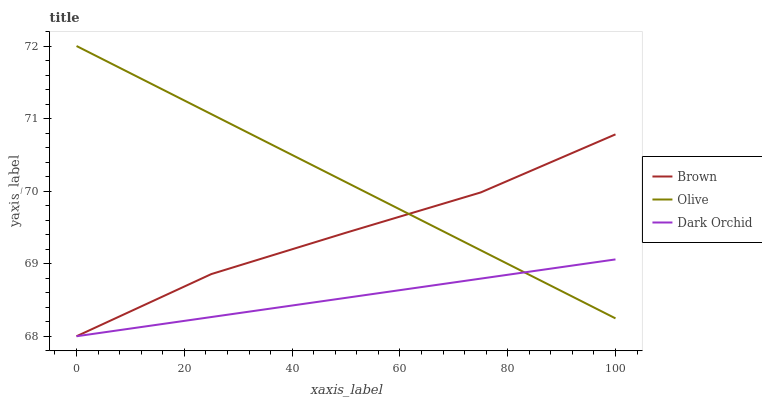Does Dark Orchid have the minimum area under the curve?
Answer yes or no. Yes. Does Olive have the maximum area under the curve?
Answer yes or no. Yes. Does Brown have the minimum area under the curve?
Answer yes or no. No. Does Brown have the maximum area under the curve?
Answer yes or no. No. Is Dark Orchid the smoothest?
Answer yes or no. Yes. Is Brown the roughest?
Answer yes or no. Yes. Is Brown the smoothest?
Answer yes or no. No. Is Dark Orchid the roughest?
Answer yes or no. No. Does Olive have the highest value?
Answer yes or no. Yes. Does Brown have the highest value?
Answer yes or no. No. Does Brown intersect Olive?
Answer yes or no. Yes. Is Brown less than Olive?
Answer yes or no. No. Is Brown greater than Olive?
Answer yes or no. No. 